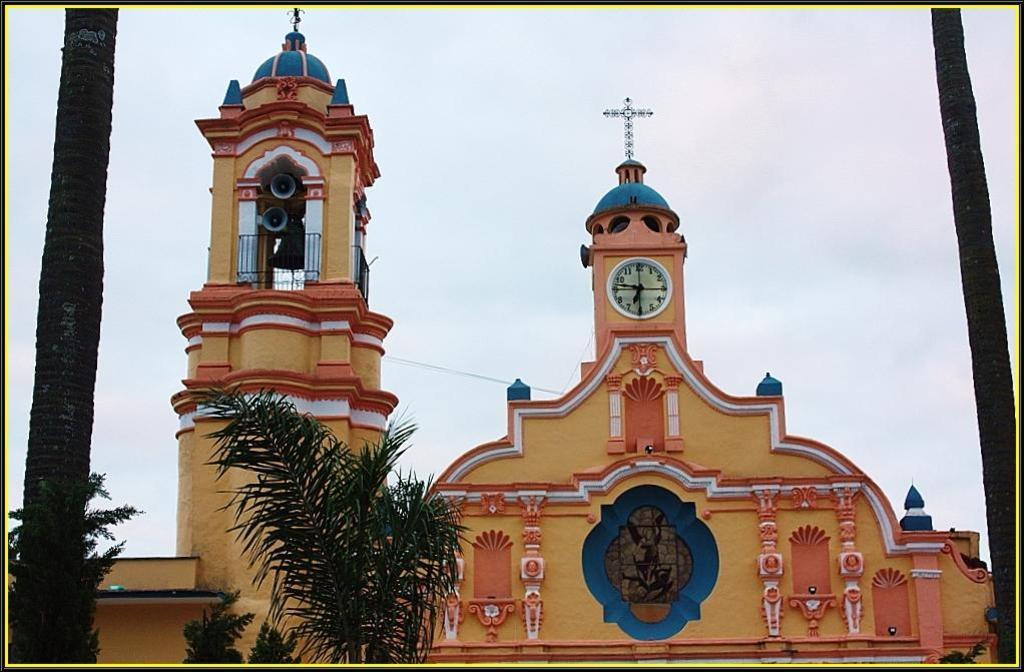How would you summarize this image in a sentence or two? In this picture we can see church. Here we can see clock which is near to this plus mark. And there are speakers which is near to this dome. On the bottom we can see trees. On the background we can see sky and clouds. 